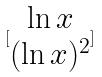<formula> <loc_0><loc_0><loc_500><loc_500>[ \begin{matrix} \ln x \\ ( \ln x ) ^ { 2 } \end{matrix} ]</formula> 